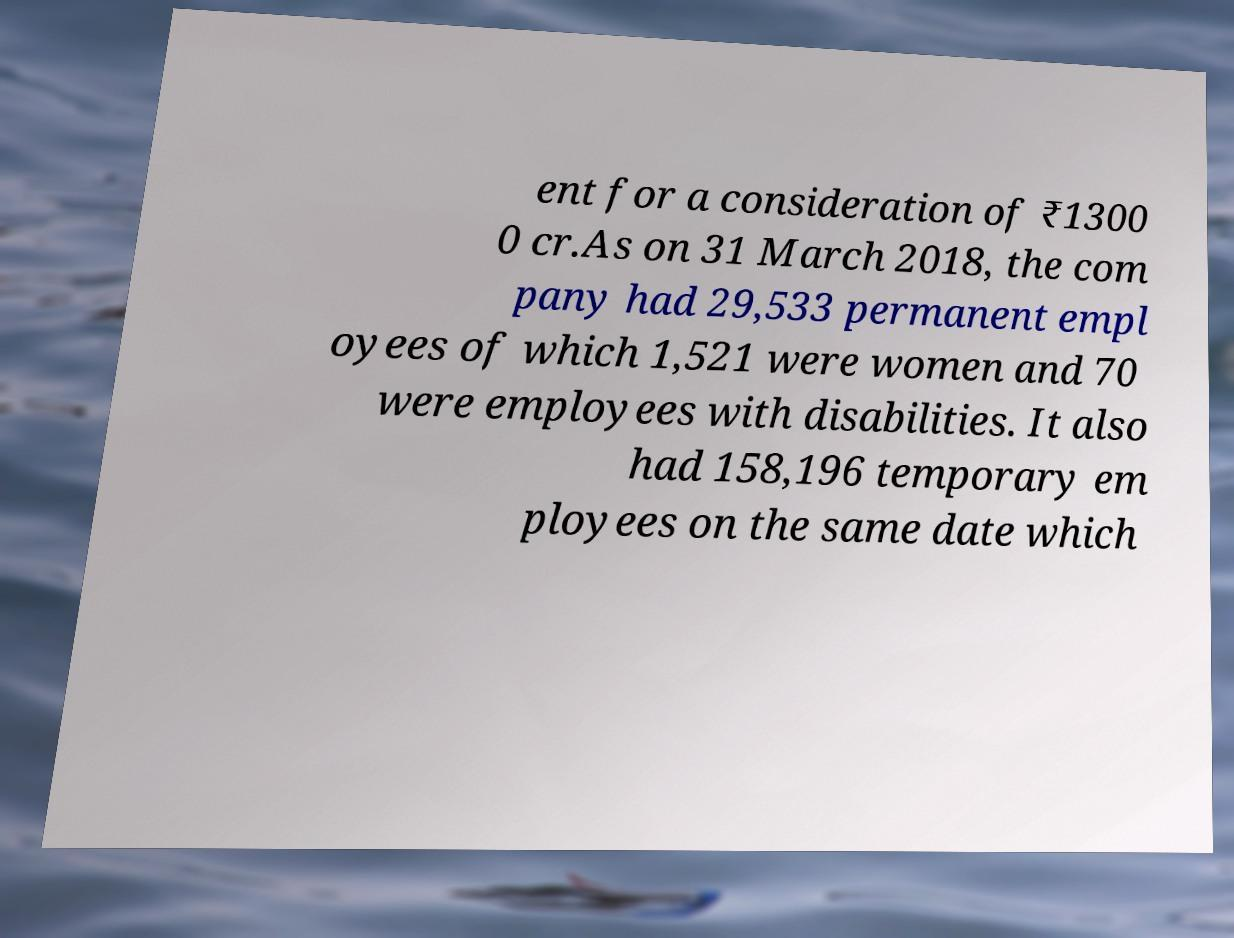Can you read and provide the text displayed in the image?This photo seems to have some interesting text. Can you extract and type it out for me? ent for a consideration of ₹1300 0 cr.As on 31 March 2018, the com pany had 29,533 permanent empl oyees of which 1,521 were women and 70 were employees with disabilities. It also had 158,196 temporary em ployees on the same date which 